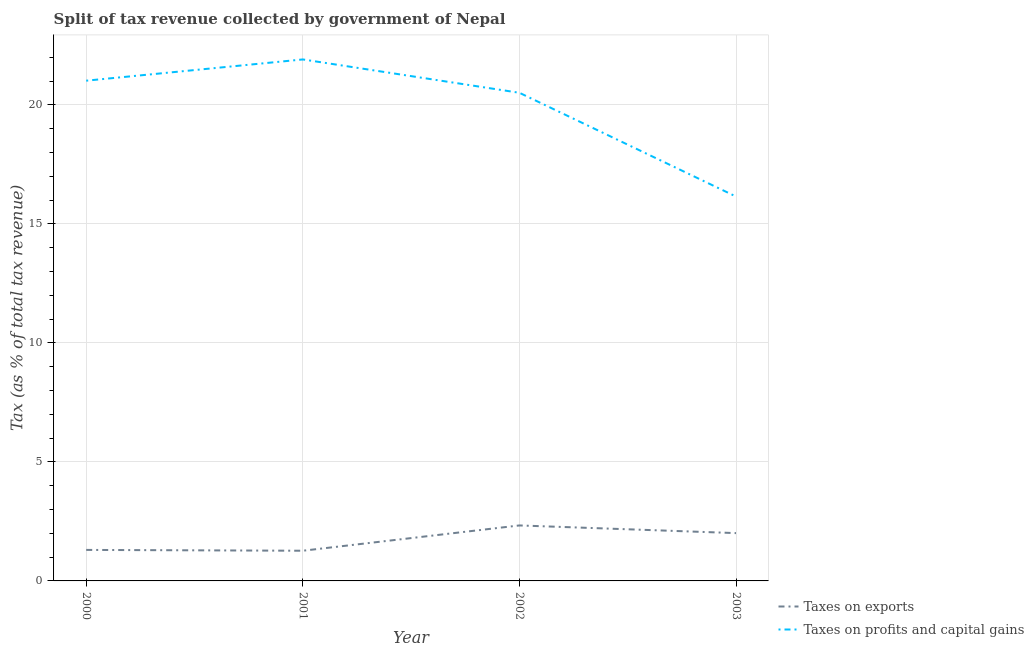How many different coloured lines are there?
Provide a succinct answer. 2. Is the number of lines equal to the number of legend labels?
Make the answer very short. Yes. What is the percentage of revenue obtained from taxes on exports in 2001?
Keep it short and to the point. 1.27. Across all years, what is the maximum percentage of revenue obtained from taxes on exports?
Make the answer very short. 2.33. Across all years, what is the minimum percentage of revenue obtained from taxes on profits and capital gains?
Provide a succinct answer. 16.15. What is the total percentage of revenue obtained from taxes on profits and capital gains in the graph?
Keep it short and to the point. 79.6. What is the difference between the percentage of revenue obtained from taxes on profits and capital gains in 2000 and that in 2001?
Your answer should be very brief. -0.89. What is the difference between the percentage of revenue obtained from taxes on profits and capital gains in 2003 and the percentage of revenue obtained from taxes on exports in 2001?
Give a very brief answer. 14.89. What is the average percentage of revenue obtained from taxes on profits and capital gains per year?
Keep it short and to the point. 19.9. In the year 2003, what is the difference between the percentage of revenue obtained from taxes on profits and capital gains and percentage of revenue obtained from taxes on exports?
Provide a short and direct response. 14.14. What is the ratio of the percentage of revenue obtained from taxes on exports in 2002 to that in 2003?
Offer a terse response. 1.16. Is the difference between the percentage of revenue obtained from taxes on profits and capital gains in 2000 and 2002 greater than the difference between the percentage of revenue obtained from taxes on exports in 2000 and 2002?
Your answer should be very brief. Yes. What is the difference between the highest and the second highest percentage of revenue obtained from taxes on profits and capital gains?
Keep it short and to the point. 0.89. What is the difference between the highest and the lowest percentage of revenue obtained from taxes on exports?
Ensure brevity in your answer.  1.06. How many lines are there?
Ensure brevity in your answer.  2. What is the difference between two consecutive major ticks on the Y-axis?
Ensure brevity in your answer.  5. Are the values on the major ticks of Y-axis written in scientific E-notation?
Give a very brief answer. No. Does the graph contain grids?
Your answer should be very brief. Yes. Where does the legend appear in the graph?
Offer a terse response. Bottom right. How are the legend labels stacked?
Provide a succinct answer. Vertical. What is the title of the graph?
Provide a short and direct response. Split of tax revenue collected by government of Nepal. What is the label or title of the X-axis?
Provide a succinct answer. Year. What is the label or title of the Y-axis?
Give a very brief answer. Tax (as % of total tax revenue). What is the Tax (as % of total tax revenue) of Taxes on exports in 2000?
Provide a short and direct response. 1.3. What is the Tax (as % of total tax revenue) of Taxes on profits and capital gains in 2000?
Your answer should be compact. 21.02. What is the Tax (as % of total tax revenue) of Taxes on exports in 2001?
Offer a terse response. 1.27. What is the Tax (as % of total tax revenue) of Taxes on profits and capital gains in 2001?
Ensure brevity in your answer.  21.91. What is the Tax (as % of total tax revenue) in Taxes on exports in 2002?
Your answer should be compact. 2.33. What is the Tax (as % of total tax revenue) in Taxes on profits and capital gains in 2002?
Offer a very short reply. 20.51. What is the Tax (as % of total tax revenue) in Taxes on exports in 2003?
Offer a terse response. 2.01. What is the Tax (as % of total tax revenue) in Taxes on profits and capital gains in 2003?
Offer a terse response. 16.15. Across all years, what is the maximum Tax (as % of total tax revenue) in Taxes on exports?
Offer a terse response. 2.33. Across all years, what is the maximum Tax (as % of total tax revenue) of Taxes on profits and capital gains?
Make the answer very short. 21.91. Across all years, what is the minimum Tax (as % of total tax revenue) of Taxes on exports?
Make the answer very short. 1.27. Across all years, what is the minimum Tax (as % of total tax revenue) in Taxes on profits and capital gains?
Offer a terse response. 16.15. What is the total Tax (as % of total tax revenue) in Taxes on exports in the graph?
Your answer should be very brief. 6.91. What is the total Tax (as % of total tax revenue) in Taxes on profits and capital gains in the graph?
Your answer should be compact. 79.6. What is the difference between the Tax (as % of total tax revenue) in Taxes on exports in 2000 and that in 2001?
Give a very brief answer. 0.03. What is the difference between the Tax (as % of total tax revenue) in Taxes on profits and capital gains in 2000 and that in 2001?
Your answer should be compact. -0.89. What is the difference between the Tax (as % of total tax revenue) of Taxes on exports in 2000 and that in 2002?
Your answer should be very brief. -1.03. What is the difference between the Tax (as % of total tax revenue) of Taxes on profits and capital gains in 2000 and that in 2002?
Your response must be concise. 0.51. What is the difference between the Tax (as % of total tax revenue) in Taxes on exports in 2000 and that in 2003?
Your answer should be very brief. -0.71. What is the difference between the Tax (as % of total tax revenue) in Taxes on profits and capital gains in 2000 and that in 2003?
Give a very brief answer. 4.87. What is the difference between the Tax (as % of total tax revenue) in Taxes on exports in 2001 and that in 2002?
Offer a terse response. -1.06. What is the difference between the Tax (as % of total tax revenue) in Taxes on profits and capital gains in 2001 and that in 2002?
Your response must be concise. 1.4. What is the difference between the Tax (as % of total tax revenue) of Taxes on exports in 2001 and that in 2003?
Your answer should be compact. -0.74. What is the difference between the Tax (as % of total tax revenue) of Taxes on profits and capital gains in 2001 and that in 2003?
Provide a short and direct response. 5.76. What is the difference between the Tax (as % of total tax revenue) in Taxes on exports in 2002 and that in 2003?
Your response must be concise. 0.32. What is the difference between the Tax (as % of total tax revenue) in Taxes on profits and capital gains in 2002 and that in 2003?
Make the answer very short. 4.36. What is the difference between the Tax (as % of total tax revenue) in Taxes on exports in 2000 and the Tax (as % of total tax revenue) in Taxes on profits and capital gains in 2001?
Provide a succinct answer. -20.61. What is the difference between the Tax (as % of total tax revenue) of Taxes on exports in 2000 and the Tax (as % of total tax revenue) of Taxes on profits and capital gains in 2002?
Offer a very short reply. -19.21. What is the difference between the Tax (as % of total tax revenue) of Taxes on exports in 2000 and the Tax (as % of total tax revenue) of Taxes on profits and capital gains in 2003?
Offer a very short reply. -14.85. What is the difference between the Tax (as % of total tax revenue) of Taxes on exports in 2001 and the Tax (as % of total tax revenue) of Taxes on profits and capital gains in 2002?
Your response must be concise. -19.24. What is the difference between the Tax (as % of total tax revenue) of Taxes on exports in 2001 and the Tax (as % of total tax revenue) of Taxes on profits and capital gains in 2003?
Offer a terse response. -14.89. What is the difference between the Tax (as % of total tax revenue) of Taxes on exports in 2002 and the Tax (as % of total tax revenue) of Taxes on profits and capital gains in 2003?
Give a very brief answer. -13.82. What is the average Tax (as % of total tax revenue) in Taxes on exports per year?
Your response must be concise. 1.73. What is the average Tax (as % of total tax revenue) of Taxes on profits and capital gains per year?
Keep it short and to the point. 19.9. In the year 2000, what is the difference between the Tax (as % of total tax revenue) in Taxes on exports and Tax (as % of total tax revenue) in Taxes on profits and capital gains?
Your answer should be very brief. -19.72. In the year 2001, what is the difference between the Tax (as % of total tax revenue) of Taxes on exports and Tax (as % of total tax revenue) of Taxes on profits and capital gains?
Give a very brief answer. -20.65. In the year 2002, what is the difference between the Tax (as % of total tax revenue) of Taxes on exports and Tax (as % of total tax revenue) of Taxes on profits and capital gains?
Provide a succinct answer. -18.18. In the year 2003, what is the difference between the Tax (as % of total tax revenue) of Taxes on exports and Tax (as % of total tax revenue) of Taxes on profits and capital gains?
Give a very brief answer. -14.14. What is the ratio of the Tax (as % of total tax revenue) in Taxes on exports in 2000 to that in 2001?
Give a very brief answer. 1.03. What is the ratio of the Tax (as % of total tax revenue) in Taxes on profits and capital gains in 2000 to that in 2001?
Your response must be concise. 0.96. What is the ratio of the Tax (as % of total tax revenue) in Taxes on exports in 2000 to that in 2002?
Offer a very short reply. 0.56. What is the ratio of the Tax (as % of total tax revenue) in Taxes on profits and capital gains in 2000 to that in 2002?
Give a very brief answer. 1.02. What is the ratio of the Tax (as % of total tax revenue) in Taxes on exports in 2000 to that in 2003?
Provide a short and direct response. 0.65. What is the ratio of the Tax (as % of total tax revenue) of Taxes on profits and capital gains in 2000 to that in 2003?
Provide a succinct answer. 1.3. What is the ratio of the Tax (as % of total tax revenue) of Taxes on exports in 2001 to that in 2002?
Keep it short and to the point. 0.54. What is the ratio of the Tax (as % of total tax revenue) in Taxes on profits and capital gains in 2001 to that in 2002?
Your response must be concise. 1.07. What is the ratio of the Tax (as % of total tax revenue) in Taxes on exports in 2001 to that in 2003?
Make the answer very short. 0.63. What is the ratio of the Tax (as % of total tax revenue) of Taxes on profits and capital gains in 2001 to that in 2003?
Offer a very short reply. 1.36. What is the ratio of the Tax (as % of total tax revenue) of Taxes on exports in 2002 to that in 2003?
Ensure brevity in your answer.  1.16. What is the ratio of the Tax (as % of total tax revenue) of Taxes on profits and capital gains in 2002 to that in 2003?
Your answer should be very brief. 1.27. What is the difference between the highest and the second highest Tax (as % of total tax revenue) of Taxes on exports?
Offer a very short reply. 0.32. What is the difference between the highest and the second highest Tax (as % of total tax revenue) of Taxes on profits and capital gains?
Your answer should be very brief. 0.89. What is the difference between the highest and the lowest Tax (as % of total tax revenue) of Taxes on exports?
Make the answer very short. 1.06. What is the difference between the highest and the lowest Tax (as % of total tax revenue) in Taxes on profits and capital gains?
Your answer should be compact. 5.76. 